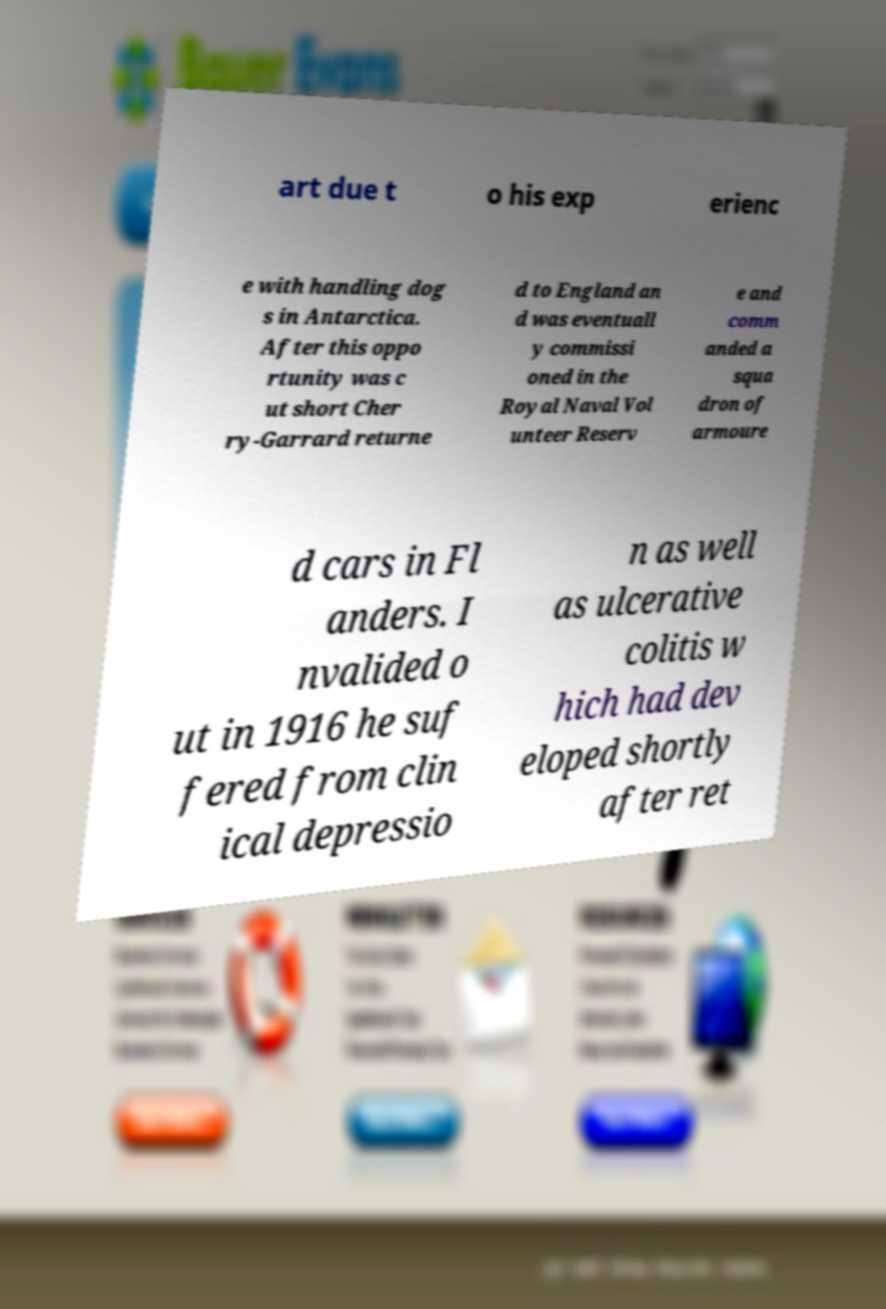For documentation purposes, I need the text within this image transcribed. Could you provide that? art due t o his exp erienc e with handling dog s in Antarctica. After this oppo rtunity was c ut short Cher ry-Garrard returne d to England an d was eventuall y commissi oned in the Royal Naval Vol unteer Reserv e and comm anded a squa dron of armoure d cars in Fl anders. I nvalided o ut in 1916 he suf fered from clin ical depressio n as well as ulcerative colitis w hich had dev eloped shortly after ret 